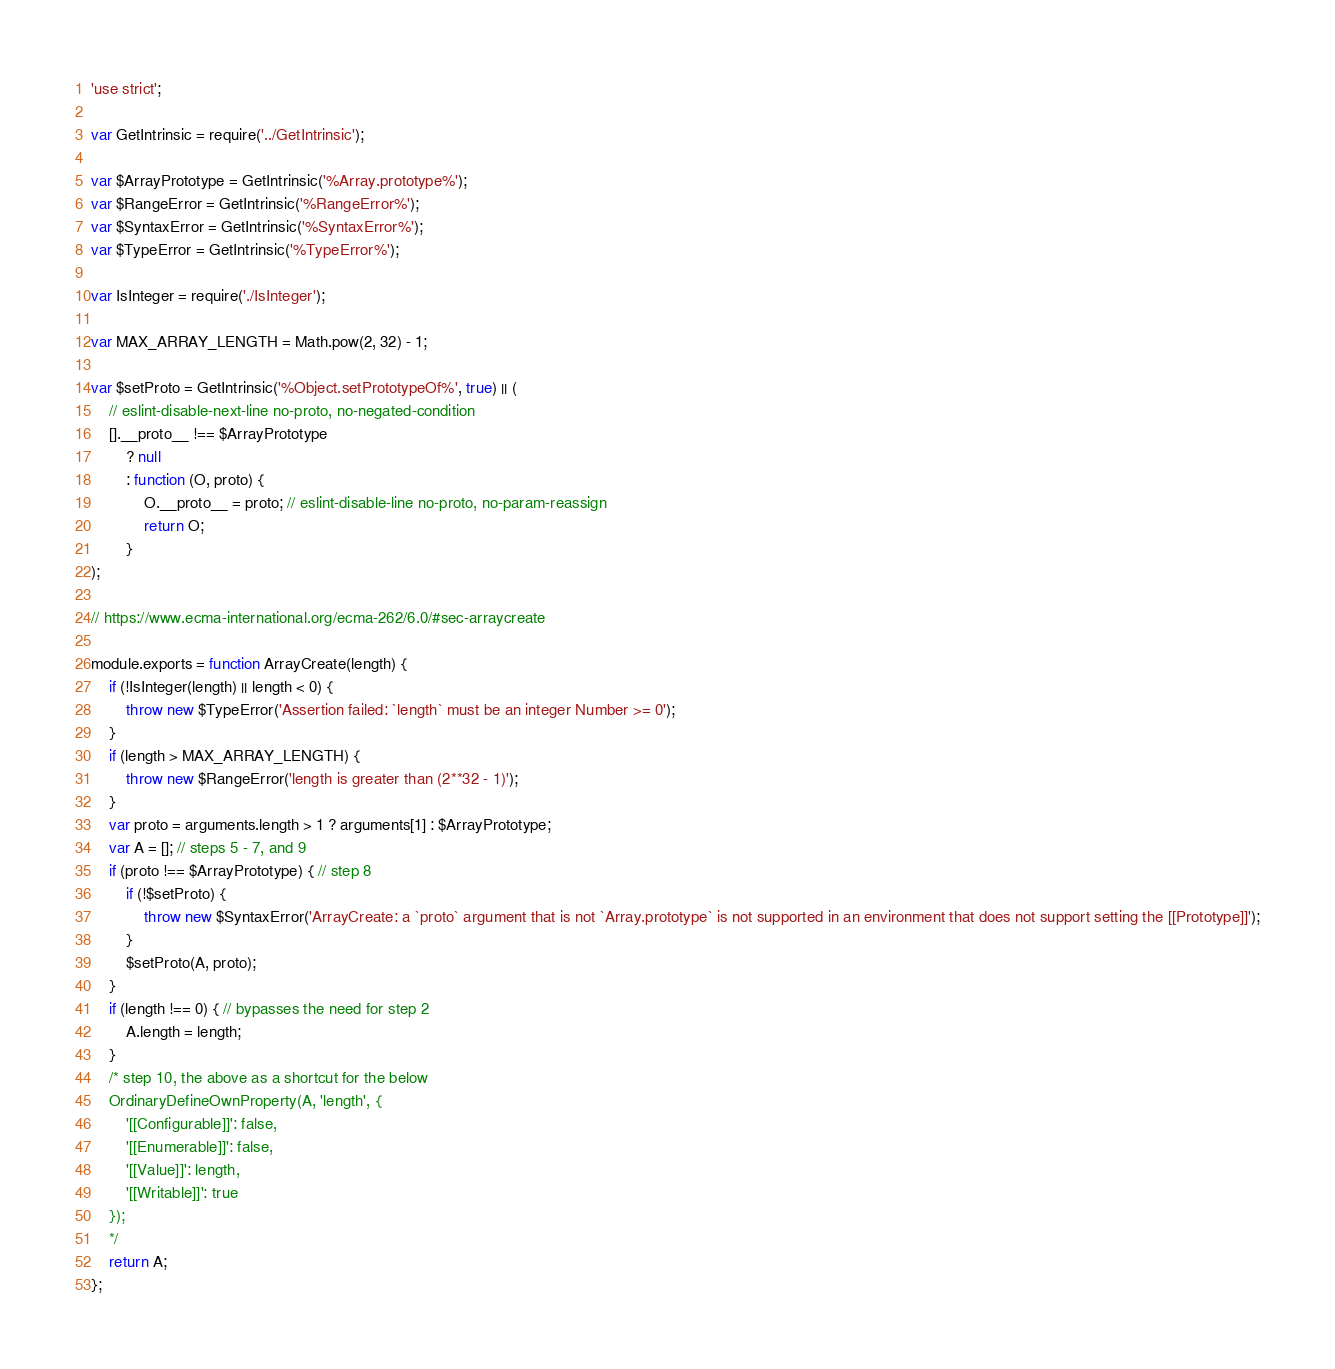Convert code to text. <code><loc_0><loc_0><loc_500><loc_500><_JavaScript_>'use strict';

var GetIntrinsic = require('../GetIntrinsic');

var $ArrayPrototype = GetIntrinsic('%Array.prototype%');
var $RangeError = GetIntrinsic('%RangeError%');
var $SyntaxError = GetIntrinsic('%SyntaxError%');
var $TypeError = GetIntrinsic('%TypeError%');

var IsInteger = require('./IsInteger');

var MAX_ARRAY_LENGTH = Math.pow(2, 32) - 1;

var $setProto = GetIntrinsic('%Object.setPrototypeOf%', true) || (
	// eslint-disable-next-line no-proto, no-negated-condition
	[].__proto__ !== $ArrayPrototype
		? null
		: function (O, proto) {
			O.__proto__ = proto; // eslint-disable-line no-proto, no-param-reassign
			return O;
		}
);

// https://www.ecma-international.org/ecma-262/6.0/#sec-arraycreate

module.exports = function ArrayCreate(length) {
	if (!IsInteger(length) || length < 0) {
		throw new $TypeError('Assertion failed: `length` must be an integer Number >= 0');
	}
	if (length > MAX_ARRAY_LENGTH) {
		throw new $RangeError('length is greater than (2**32 - 1)');
	}
	var proto = arguments.length > 1 ? arguments[1] : $ArrayPrototype;
	var A = []; // steps 5 - 7, and 9
	if (proto !== $ArrayPrototype) { // step 8
		if (!$setProto) {
			throw new $SyntaxError('ArrayCreate: a `proto` argument that is not `Array.prototype` is not supported in an environment that does not support setting the [[Prototype]]');
		}
		$setProto(A, proto);
	}
	if (length !== 0) { // bypasses the need for step 2
		A.length = length;
	}
	/* step 10, the above as a shortcut for the below
    OrdinaryDefineOwnProperty(A, 'length', {
        '[[Configurable]]': false,
        '[[Enumerable]]': false,
        '[[Value]]': length,
        '[[Writable]]': true
    });
    */
	return A;
};
</code> 